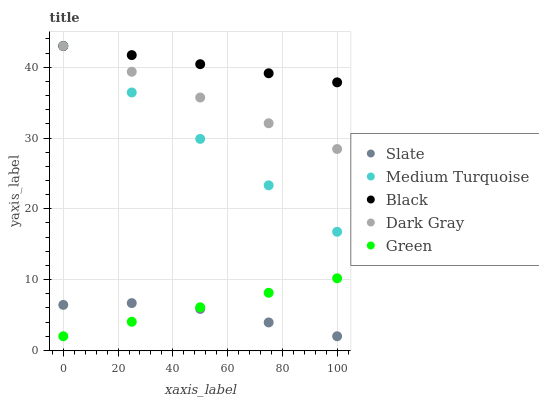Does Slate have the minimum area under the curve?
Answer yes or no. Yes. Does Black have the maximum area under the curve?
Answer yes or no. Yes. Does Green have the minimum area under the curve?
Answer yes or no. No. Does Green have the maximum area under the curve?
Answer yes or no. No. Is Black the smoothest?
Answer yes or no. Yes. Is Slate the roughest?
Answer yes or no. Yes. Is Green the smoothest?
Answer yes or no. No. Is Green the roughest?
Answer yes or no. No. Does Green have the lowest value?
Answer yes or no. Yes. Does Black have the lowest value?
Answer yes or no. No. Does Medium Turquoise have the highest value?
Answer yes or no. Yes. Does Green have the highest value?
Answer yes or no. No. Is Green less than Dark Gray?
Answer yes or no. Yes. Is Dark Gray greater than Slate?
Answer yes or no. Yes. Does Green intersect Slate?
Answer yes or no. Yes. Is Green less than Slate?
Answer yes or no. No. Is Green greater than Slate?
Answer yes or no. No. Does Green intersect Dark Gray?
Answer yes or no. No. 